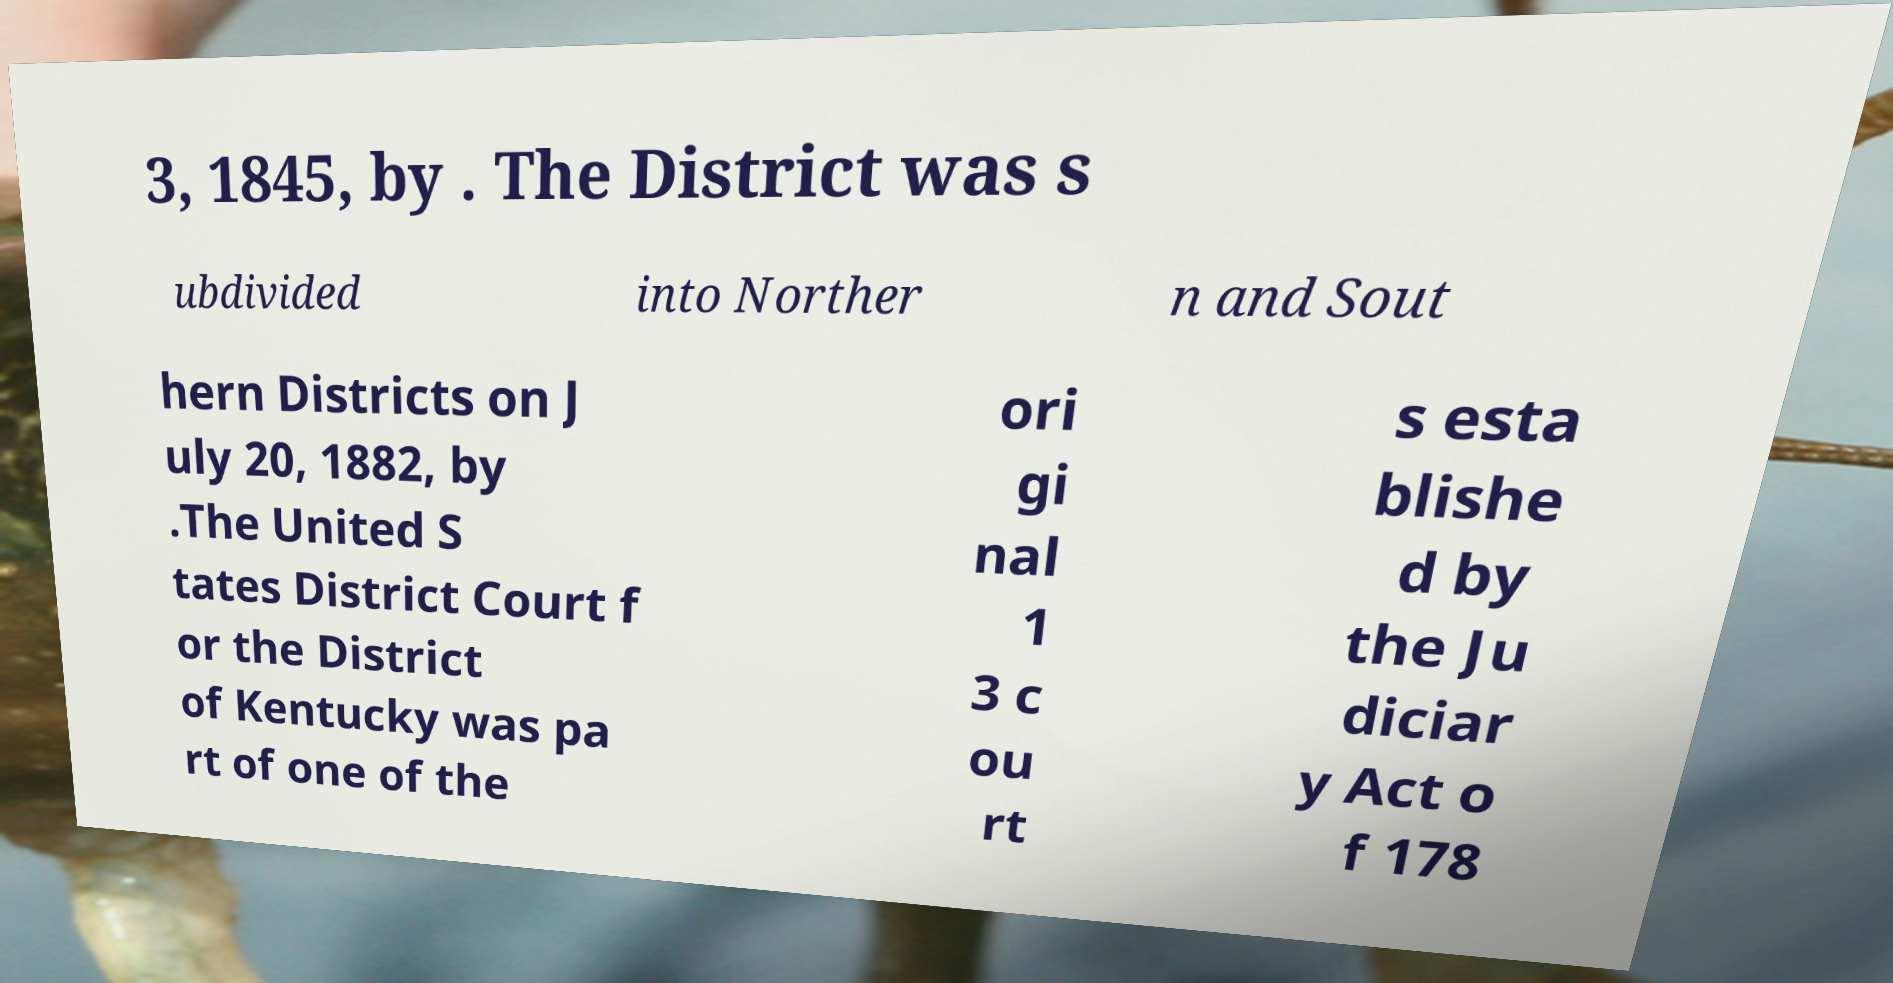Can you accurately transcribe the text from the provided image for me? 3, 1845, by . The District was s ubdivided into Norther n and Sout hern Districts on J uly 20, 1882, by .The United S tates District Court f or the District of Kentucky was pa rt of one of the ori gi nal 1 3 c ou rt s esta blishe d by the Ju diciar y Act o f 178 